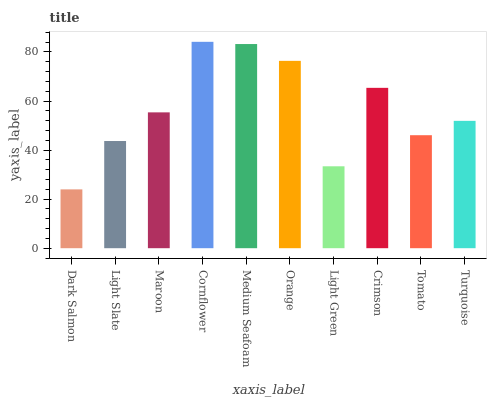Is Light Slate the minimum?
Answer yes or no. No. Is Light Slate the maximum?
Answer yes or no. No. Is Light Slate greater than Dark Salmon?
Answer yes or no. Yes. Is Dark Salmon less than Light Slate?
Answer yes or no. Yes. Is Dark Salmon greater than Light Slate?
Answer yes or no. No. Is Light Slate less than Dark Salmon?
Answer yes or no. No. Is Maroon the high median?
Answer yes or no. Yes. Is Turquoise the low median?
Answer yes or no. Yes. Is Light Green the high median?
Answer yes or no. No. Is Cornflower the low median?
Answer yes or no. No. 